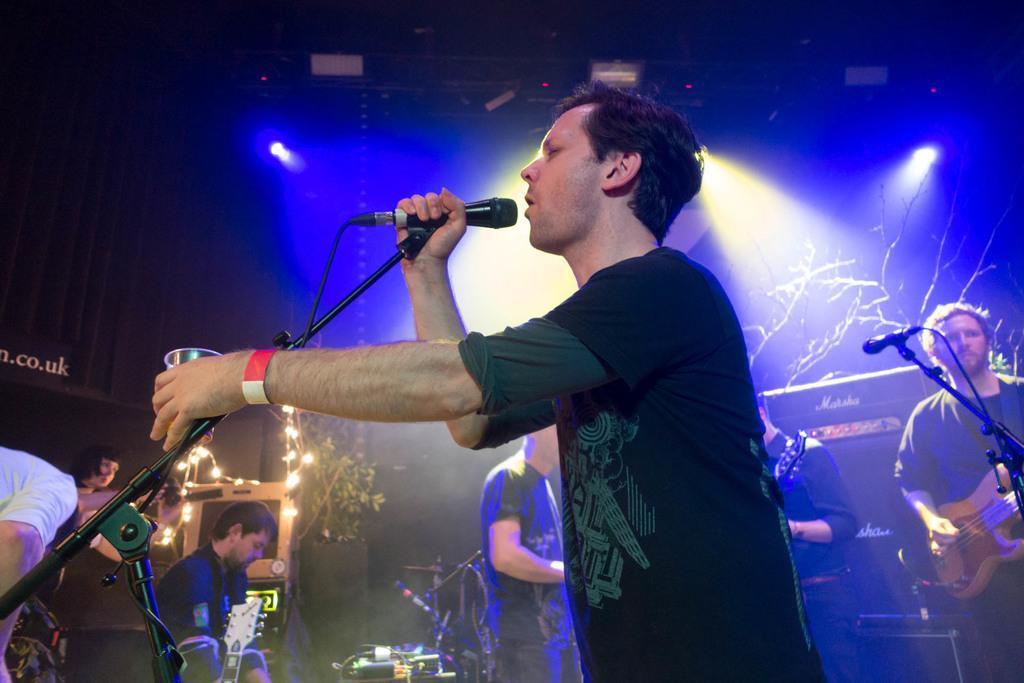Can you describe this image briefly? In the image we can see there is a person who is standing and holding mic in his hand and others are playing musical instruments. In the back side there is plants and other lightings. 